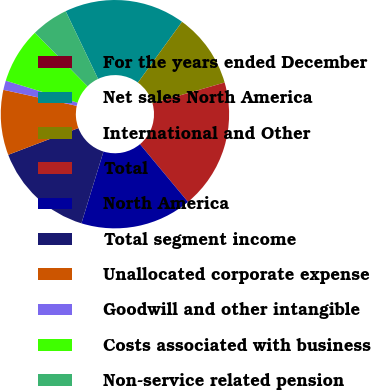Convert chart. <chart><loc_0><loc_0><loc_500><loc_500><pie_chart><fcel>For the years ended December<fcel>Net sales North America<fcel>International and Other<fcel>Total<fcel>North America<fcel>Total segment income<fcel>Unallocated corporate expense<fcel>Goodwill and other intangible<fcel>Costs associated with business<fcel>Non-service related pension<nl><fcel>0.0%<fcel>17.1%<fcel>10.53%<fcel>18.42%<fcel>15.79%<fcel>14.47%<fcel>9.21%<fcel>1.32%<fcel>7.9%<fcel>5.26%<nl></chart> 